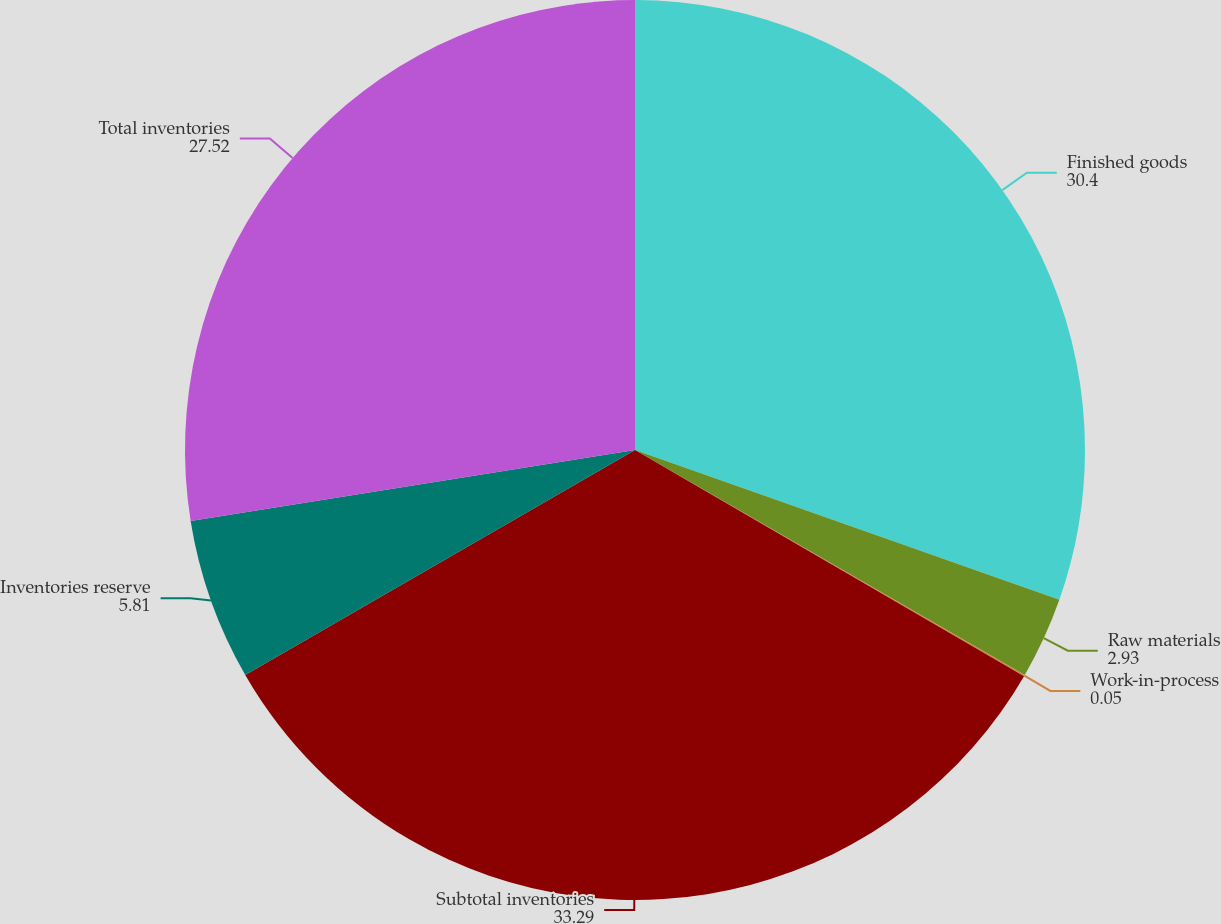<chart> <loc_0><loc_0><loc_500><loc_500><pie_chart><fcel>Finished goods<fcel>Raw materials<fcel>Work-in-process<fcel>Subtotal inventories<fcel>Inventories reserve<fcel>Total inventories<nl><fcel>30.4%<fcel>2.93%<fcel>0.05%<fcel>33.29%<fcel>5.81%<fcel>27.52%<nl></chart> 